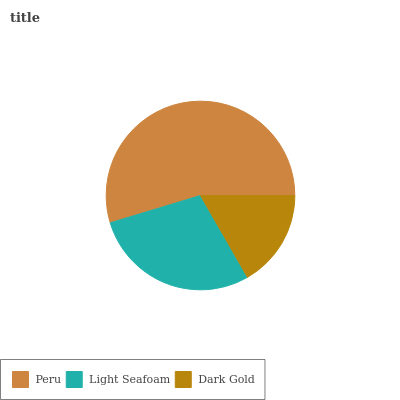Is Dark Gold the minimum?
Answer yes or no. Yes. Is Peru the maximum?
Answer yes or no. Yes. Is Light Seafoam the minimum?
Answer yes or no. No. Is Light Seafoam the maximum?
Answer yes or no. No. Is Peru greater than Light Seafoam?
Answer yes or no. Yes. Is Light Seafoam less than Peru?
Answer yes or no. Yes. Is Light Seafoam greater than Peru?
Answer yes or no. No. Is Peru less than Light Seafoam?
Answer yes or no. No. Is Light Seafoam the high median?
Answer yes or no. Yes. Is Light Seafoam the low median?
Answer yes or no. Yes. Is Peru the high median?
Answer yes or no. No. Is Peru the low median?
Answer yes or no. No. 